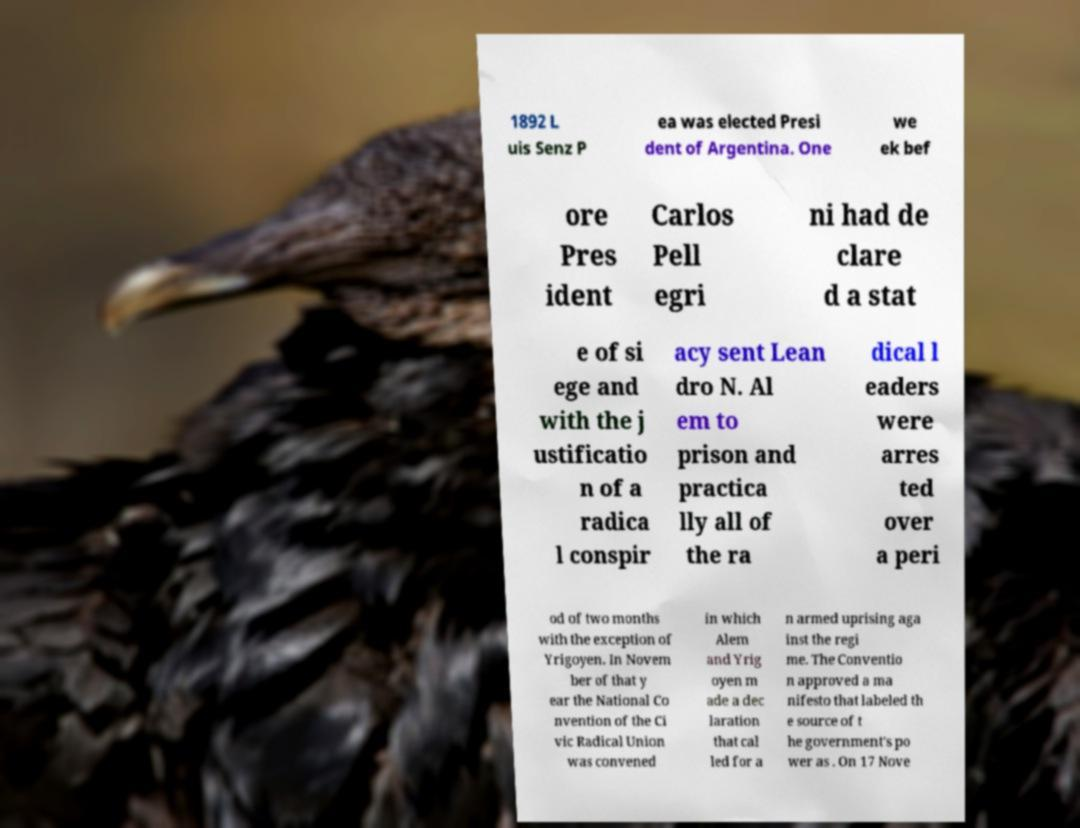Please identify and transcribe the text found in this image. 1892 L uis Senz P ea was elected Presi dent of Argentina. One we ek bef ore Pres ident Carlos Pell egri ni had de clare d a stat e of si ege and with the j ustificatio n of a radica l conspir acy sent Lean dro N. Al em to prison and practica lly all of the ra dical l eaders were arres ted over a peri od of two months with the exception of Yrigoyen. In Novem ber of that y ear the National Co nvention of the Ci vic Radical Union was convened in which Alem and Yrig oyen m ade a dec laration that cal led for a n armed uprising aga inst the regi me. The Conventio n approved a ma nifesto that labeled th e source of t he government's po wer as . On 17 Nove 